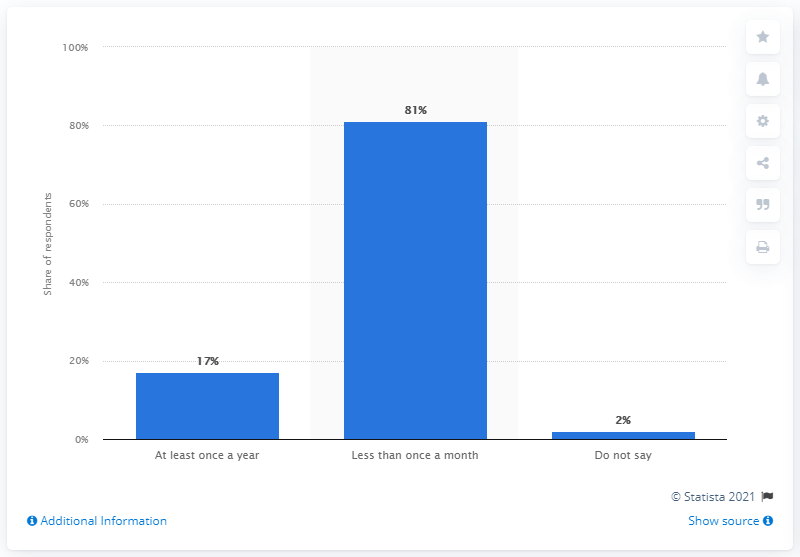Indicate a few pertinent items in this graphic. According to a survey of French individuals, 17% reported having illegally downloaded movies on the internet at least once a year. 